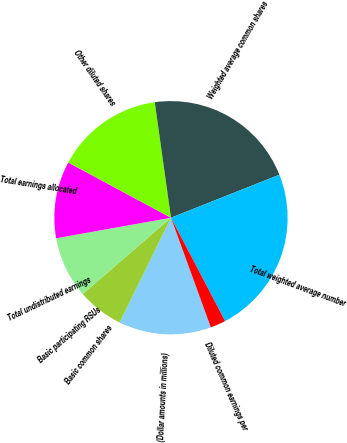Convert chart to OTSL. <chart><loc_0><loc_0><loc_500><loc_500><pie_chart><fcel>(Dollar amounts in millions)<fcel>Basic common shares<fcel>Basic participating RSUs<fcel>Total undistributed earnings<fcel>Total earnings allocated<fcel>Other diluted shares<fcel>Weighted average common shares<fcel>Total weighted average number<fcel>Diluted common earnings per<nl><fcel>12.8%<fcel>6.4%<fcel>0.0%<fcel>8.53%<fcel>10.67%<fcel>14.93%<fcel>21.2%<fcel>23.33%<fcel>2.13%<nl></chart> 